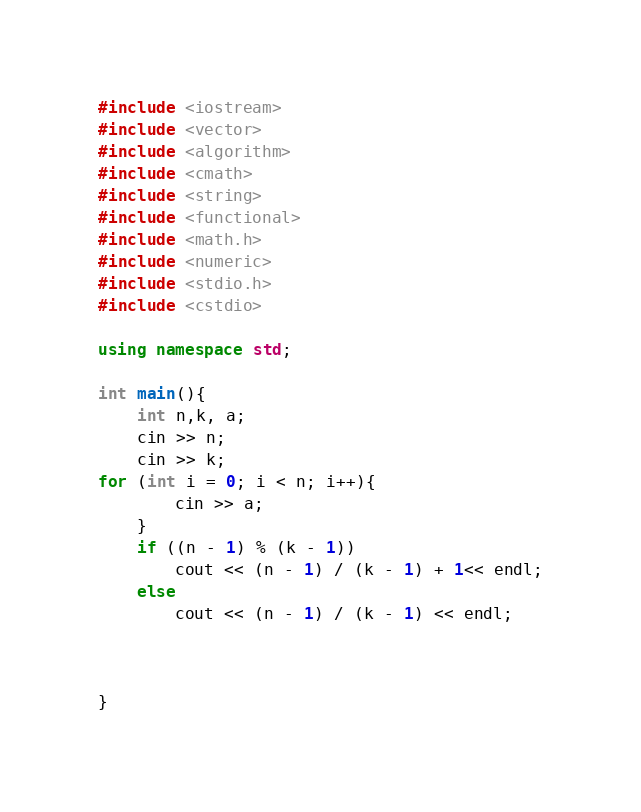Convert code to text. <code><loc_0><loc_0><loc_500><loc_500><_C++_>#include <iostream>
#include <vector>
#include <algorithm>
#include <cmath>
#include <string>
#include <functional>
#include <math.h>
#include <numeric>
#include <stdio.h>
#include <cstdio>

using namespace std;

int main(){
    int n,k, a;
    cin >> n;
    cin >> k;
for (int i = 0; i < n; i++){
        cin >> a;
    }
    if ((n - 1) % (k - 1))
        cout << (n - 1) / (k - 1) + 1<< endl;
    else
        cout << (n - 1) / (k - 1) << endl;
    
    
    
}
</code> 